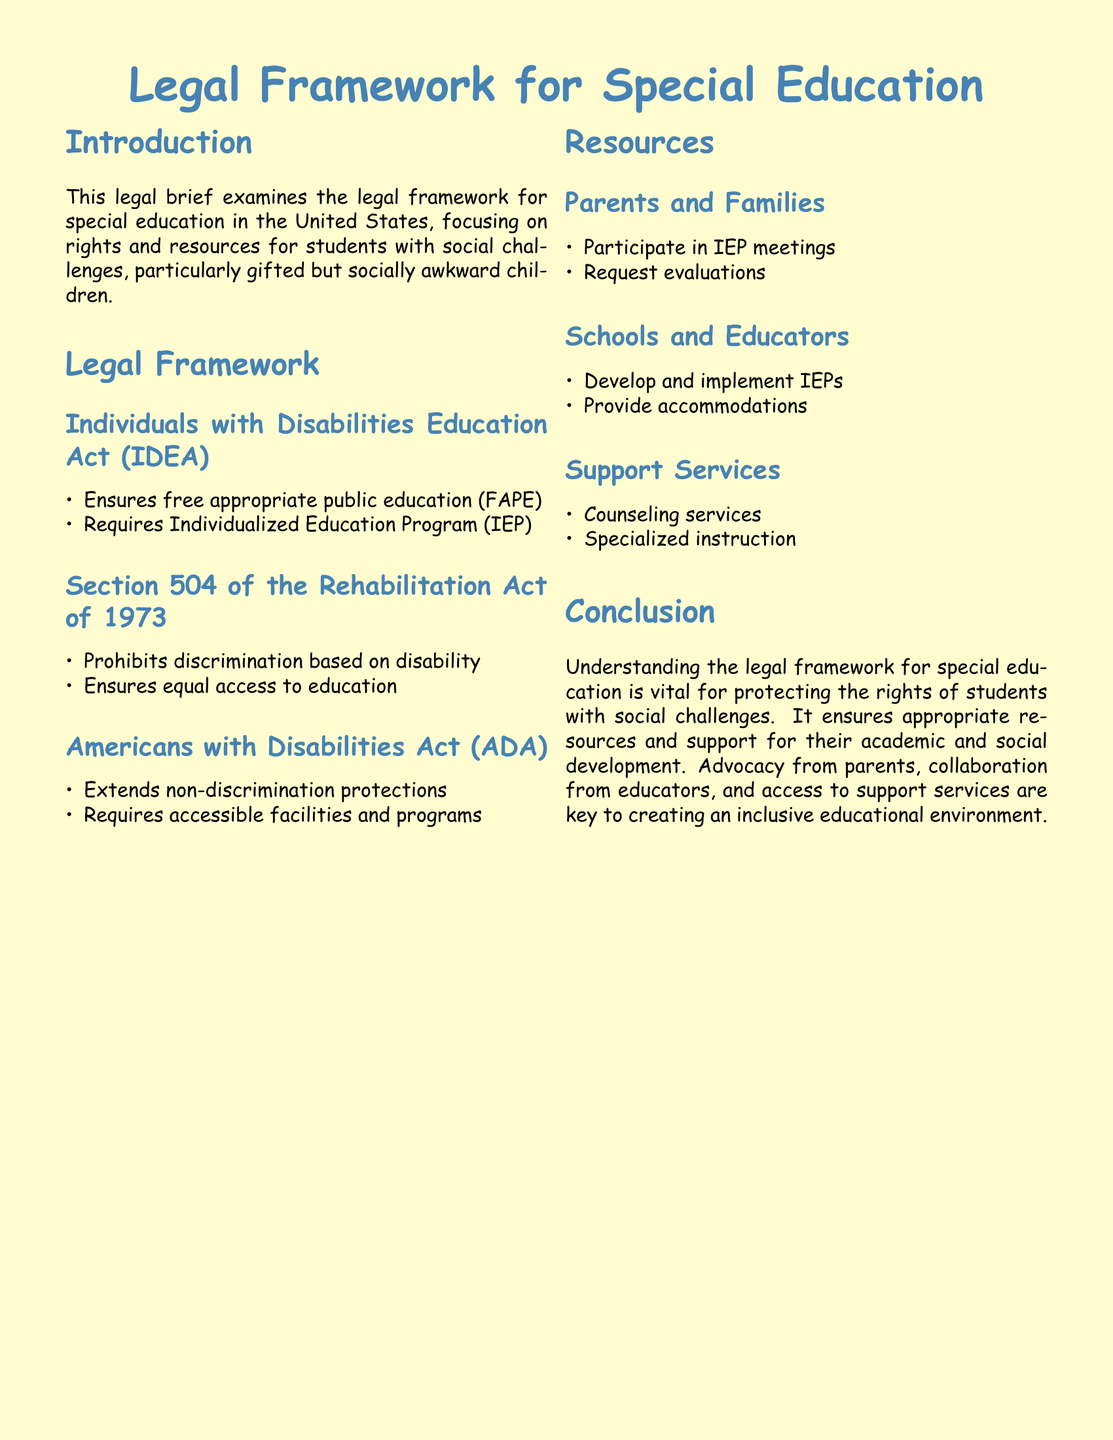What is the primary focus of the legal brief? The primary focus is on rights and resources for students with social challenges, particularly gifted but socially awkward children.
Answer: rights and resources for students with social challenges What does IDEA stand for? IDEA stands for Individuals with Disabilities Education Act, as mentioned in the legal framework section.
Answer: Individuals with Disabilities Education Act What does FAPE ensure? FAPE ensures free appropriate public education as outlined in the Individuals with Disabilities Education Act (IDEA).
Answer: free appropriate public education What are two examples of support services mentioned? The document lists counseling services and specialized instruction as examples of support services.
Answer: counseling services, specialized instruction What year was Section 504 of the Rehabilitation Act enacted? Section 504 of the Rehabilitation Act was enacted in 1973, as stated in the document.
Answer: 1973 Who develops and implements IEPs? The schools and educators are responsible for developing and implementing IEPs according to the resources section.
Answer: Schools and Educators What is the main purpose of the Americans with Disabilities Act (ADA)? The Americans with Disabilities Act (ADA) extends non-discrimination protections to individuals.
Answer: non-discrimination protections What role do parents and families have in the special education process? Parents and families can participate in IEP meetings and request evaluations as mentioned in the resources section.
Answer: Participate in IEP meetings, request evaluations What is the overall goal of the legal framework for special education? The overall goal is to protect the rights of students with social challenges and ensure they receive appropriate resources and support.
Answer: protect the rights of students with social challenges 